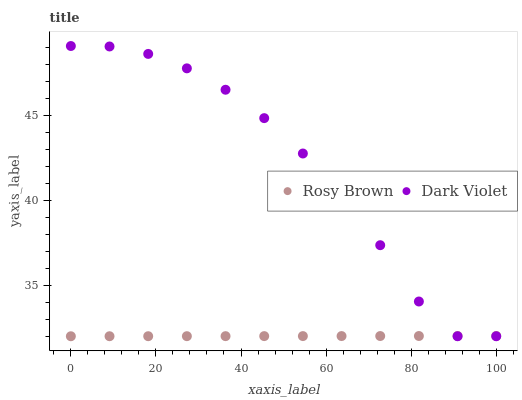Does Rosy Brown have the minimum area under the curve?
Answer yes or no. Yes. Does Dark Violet have the maximum area under the curve?
Answer yes or no. Yes. Does Dark Violet have the minimum area under the curve?
Answer yes or no. No. Is Rosy Brown the smoothest?
Answer yes or no. Yes. Is Dark Violet the roughest?
Answer yes or no. Yes. Is Dark Violet the smoothest?
Answer yes or no. No. Does Rosy Brown have the lowest value?
Answer yes or no. Yes. Does Dark Violet have the highest value?
Answer yes or no. Yes. Does Dark Violet intersect Rosy Brown?
Answer yes or no. Yes. Is Dark Violet less than Rosy Brown?
Answer yes or no. No. Is Dark Violet greater than Rosy Brown?
Answer yes or no. No. 